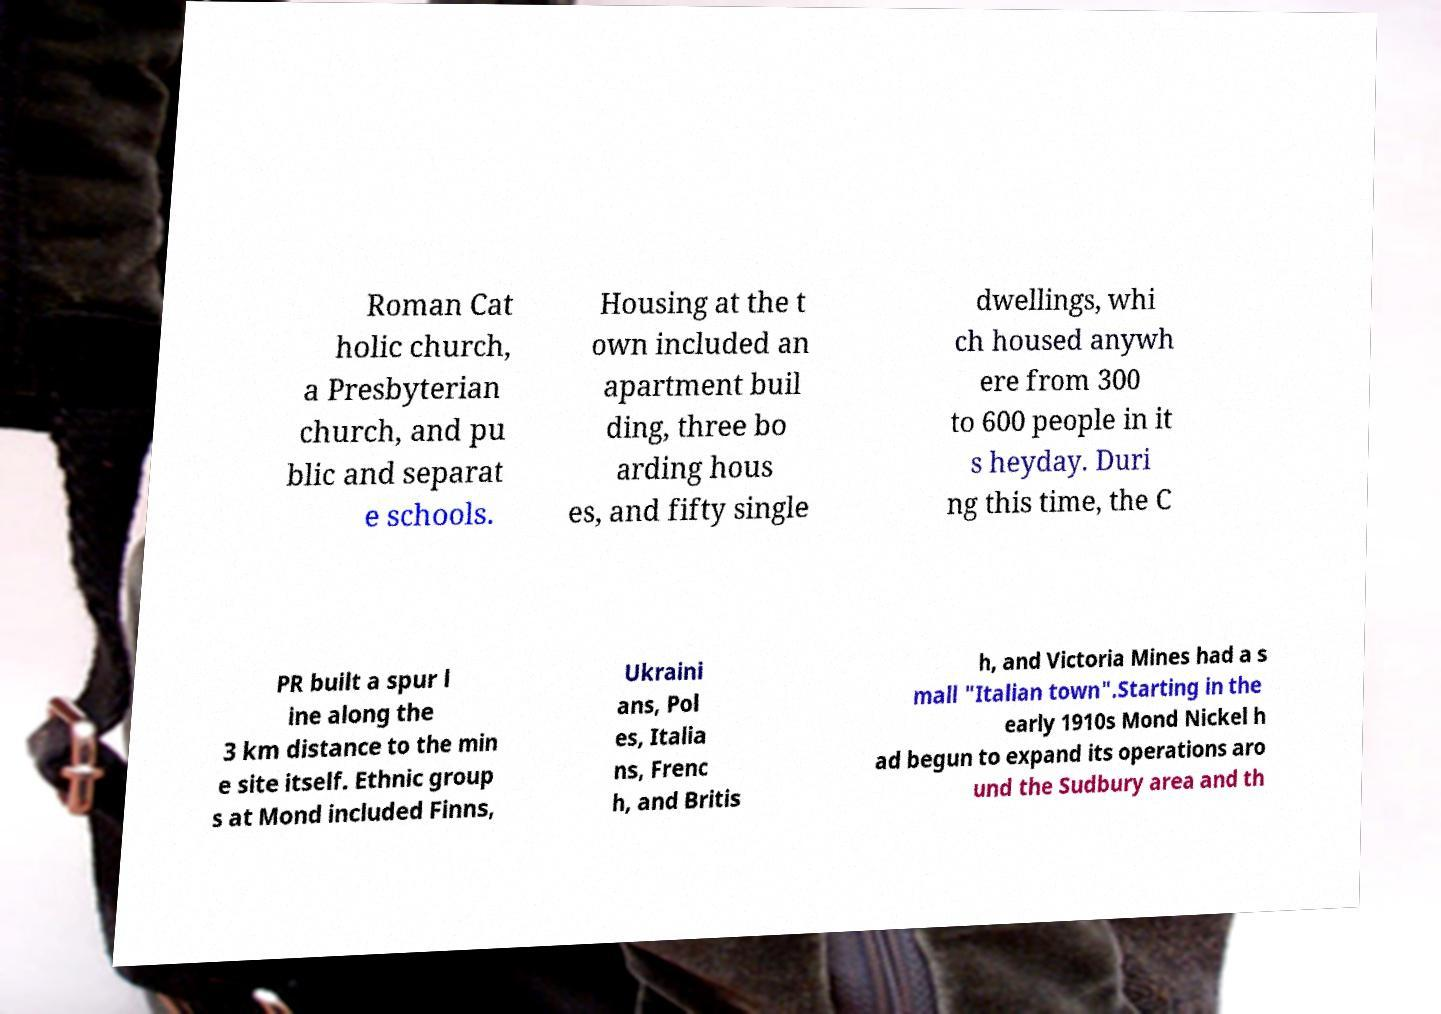There's text embedded in this image that I need extracted. Can you transcribe it verbatim? Roman Cat holic church, a Presbyterian church, and pu blic and separat e schools. Housing at the t own included an apartment buil ding, three bo arding hous es, and fifty single dwellings, whi ch housed anywh ere from 300 to 600 people in it s heyday. Duri ng this time, the C PR built a spur l ine along the 3 km distance to the min e site itself. Ethnic group s at Mond included Finns, Ukraini ans, Pol es, Italia ns, Frenc h, and Britis h, and Victoria Mines had a s mall "Italian town".Starting in the early 1910s Mond Nickel h ad begun to expand its operations aro und the Sudbury area and th 